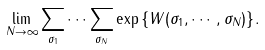<formula> <loc_0><loc_0><loc_500><loc_500>\lim _ { N \rightarrow \infty } \sum _ { \sigma _ { 1 } } \cdots \sum _ { \sigma _ { N } } \exp { \{ W ( \sigma _ { 1 } , \cdots , \sigma _ { N } ) \} } .</formula> 